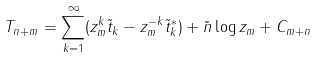<formula> <loc_0><loc_0><loc_500><loc_500>T _ { n + m } = \sum _ { k = 1 } ^ { \infty } ( z _ { m } ^ { k } \tilde { t } _ { k } - z _ { m } ^ { - k } \tilde { t } ^ { * } _ { k } ) + { \tilde { n } } \log z _ { m } + C _ { m + n }</formula> 